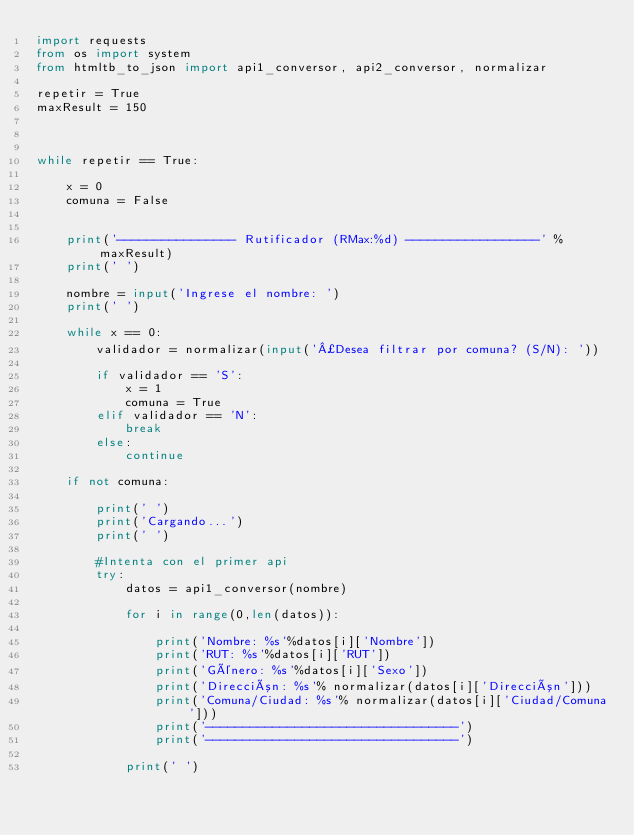<code> <loc_0><loc_0><loc_500><loc_500><_Python_>import requests
from os import system
from htmltb_to_json import api1_conversor, api2_conversor, normalizar

repetir = True
maxResult = 150



while repetir == True:

    x = 0
    comuna = False
    

    print('---------------- Rutificador (RMax:%d) ------------------' % maxResult)
    print(' ')

    nombre = input('Ingrese el nombre: ')
    print(' ')

    while x == 0:
        validador = normalizar(input('¿Desea filtrar por comuna? (S/N): '))

        if validador == 'S':
            x = 1
            comuna = True
        elif validador == 'N':
            break
        else:
            continue

    if not comuna:
        
        print(' ')
        print('Cargando...')
        print(' ')

        #Intenta con el primer api
        try:
            datos = api1_conversor(nombre)

            for i in range(0,len(datos)):

                print('Nombre: %s'%datos[i]['Nombre'])
                print('RUT: %s'%datos[i]['RUT'])
                print('Género: %s'%datos[i]['Sexo'])
                print('Dirección: %s'% normalizar(datos[i]['Dirección']))
                print('Comuna/Ciudad: %s'% normalizar(datos[i]['Ciudad/Comuna']))
                print('----------------------------------')
                print('----------------------------------')

            print(' ')</code> 